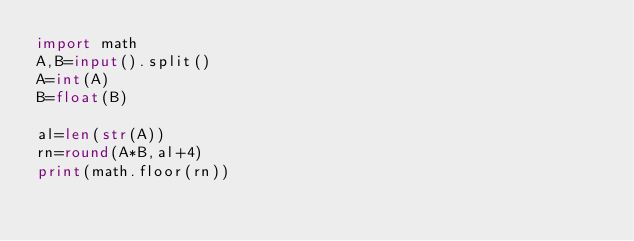Convert code to text. <code><loc_0><loc_0><loc_500><loc_500><_Python_>import math
A,B=input().split()
A=int(A)
B=float(B)

al=len(str(A))
rn=round(A*B,al+4)
print(math.floor(rn))</code> 